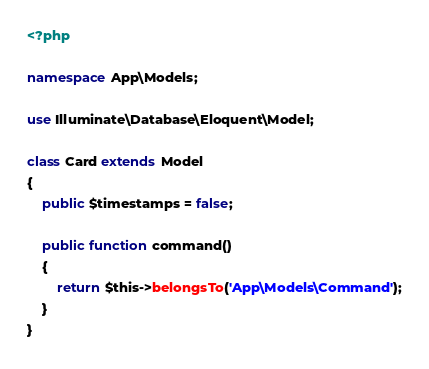Convert code to text. <code><loc_0><loc_0><loc_500><loc_500><_PHP_><?php

namespace App\Models;

use Illuminate\Database\Eloquent\Model;

class Card extends Model
{
    public $timestamps = false;

    public function command()
    {
        return $this->belongsTo('App\Models\Command');
    }
}
</code> 